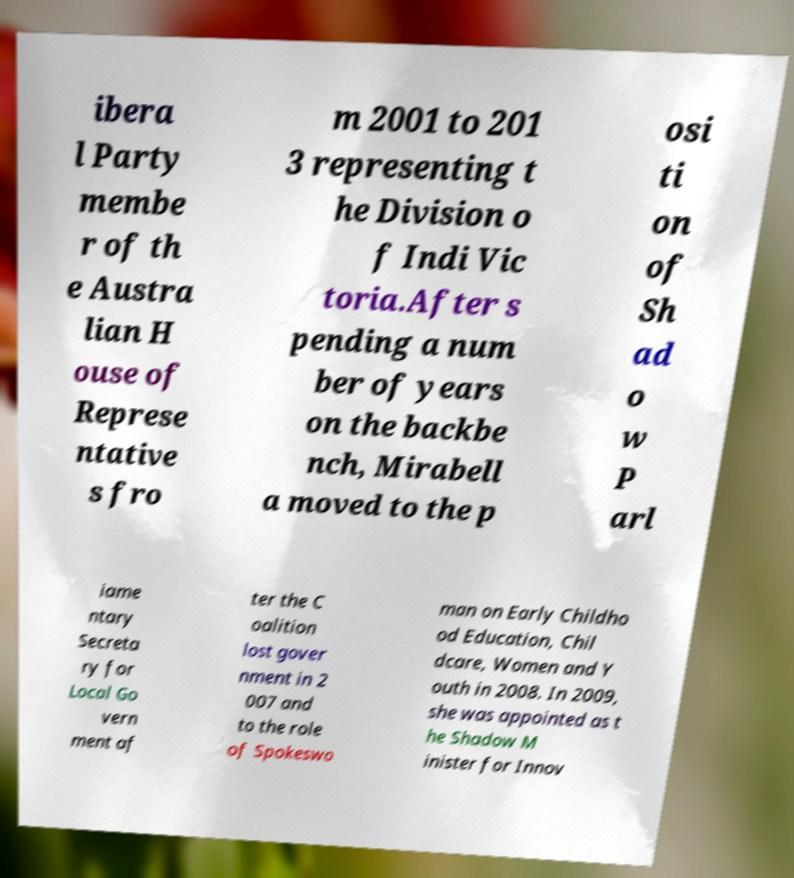Please identify and transcribe the text found in this image. ibera l Party membe r of th e Austra lian H ouse of Represe ntative s fro m 2001 to 201 3 representing t he Division o f Indi Vic toria.After s pending a num ber of years on the backbe nch, Mirabell a moved to the p osi ti on of Sh ad o w P arl iame ntary Secreta ry for Local Go vern ment af ter the C oalition lost gover nment in 2 007 and to the role of Spokeswo man on Early Childho od Education, Chil dcare, Women and Y outh in 2008. In 2009, she was appointed as t he Shadow M inister for Innov 